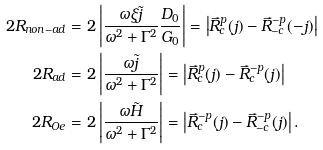<formula> <loc_0><loc_0><loc_500><loc_500>2 R _ { n o n - a d } & = 2 \left | \frac { \omega \xi \tilde { j } } { \omega ^ { 2 } + \Gamma ^ { 2 } } \frac { D _ { 0 } } { G _ { 0 } } \right | = \left | \vec { R } _ { c } ^ { p } ( j ) - \vec { R } _ { - c } ^ { - p } ( - j ) \right | \\ 2 R _ { a d } & = 2 \left | \frac { \omega \tilde { j } } { \omega ^ { 2 } + \Gamma ^ { 2 } } \right | = \left | \vec { R } _ { c } ^ { p } ( j ) - \vec { R } _ { c } ^ { - p } ( j ) \right | \\ 2 R _ { O e } & = 2 \left | \frac { \omega \tilde { H } } { \omega ^ { 2 } + \Gamma ^ { 2 } } \right | = \left | \vec { R } _ { c } ^ { - p } ( j ) - \vec { R } _ { - c } ^ { - p } ( j ) \right | .</formula> 